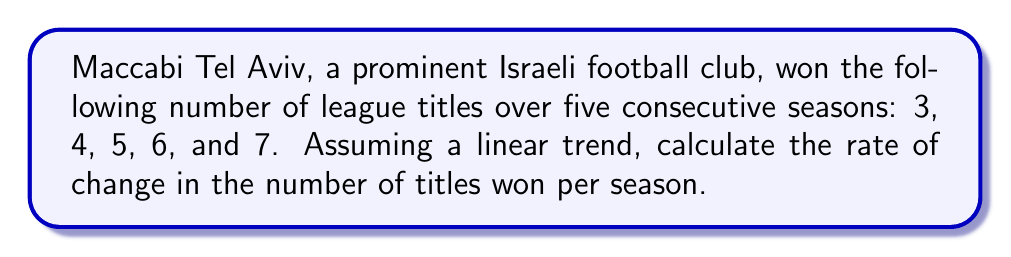Show me your answer to this math problem. To determine the rate of change, we'll use the slope formula:

$$ m = \frac{y_2 - y_1}{x_2 - x_1} $$

Where:
$m$ is the rate of change (slope)
$(x_1, y_1)$ is the initial point
$(x_2, y_2)$ is the final point

1. Identify the points:
   Initial point $(x_1, y_1)$: (1, 3)
   Final point $(x_2, y_2)$: (5, 7)

2. Plug these values into the slope formula:

   $$ m = \frac{7 - 3}{5 - 1} = \frac{4}{4} = 1 $$

3. Interpret the result:
   The rate of change is 1 title per season, indicating that Maccabi Tel Aviv's performance, in terms of league titles won, improved by 1 title each season over the given period.
Answer: 1 title per season 